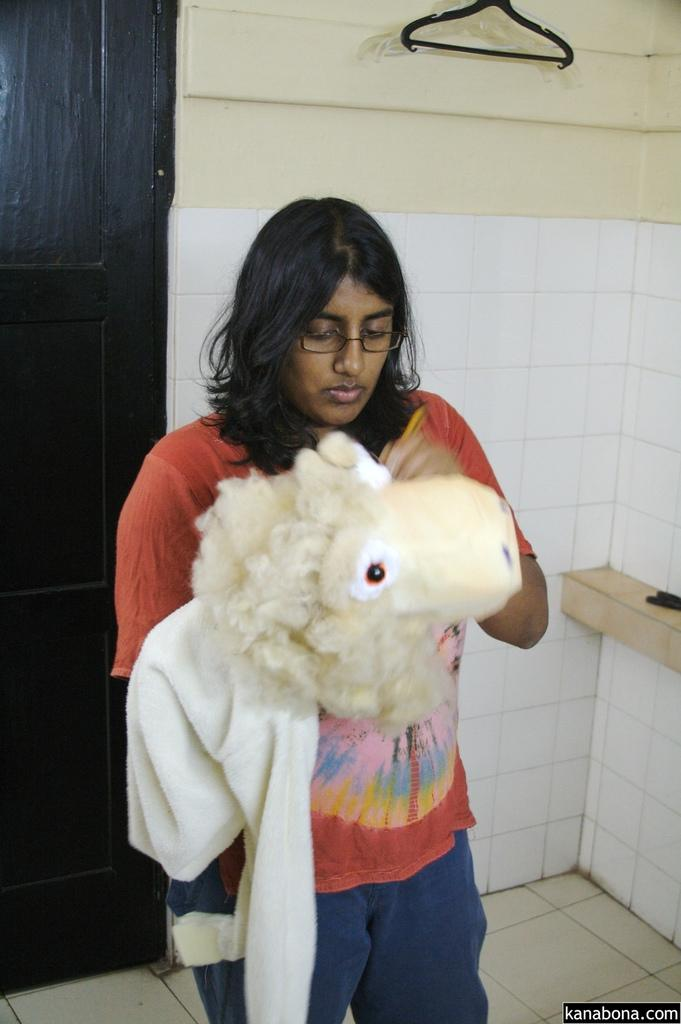What is the girl in the image doing? The girl is standing in the image. What is the girl holding in the image? The girl is holding a doll. What can be seen on the wall in the image? There is a hanger on the wall in the image. Can you see any bees buzzing around the girl in the image? There are no bees visible in the image. What type of amusement park can be seen in the background of the image? There is no amusement park present in the image; it only features a girl, a doll, and a hanger on the wall. 